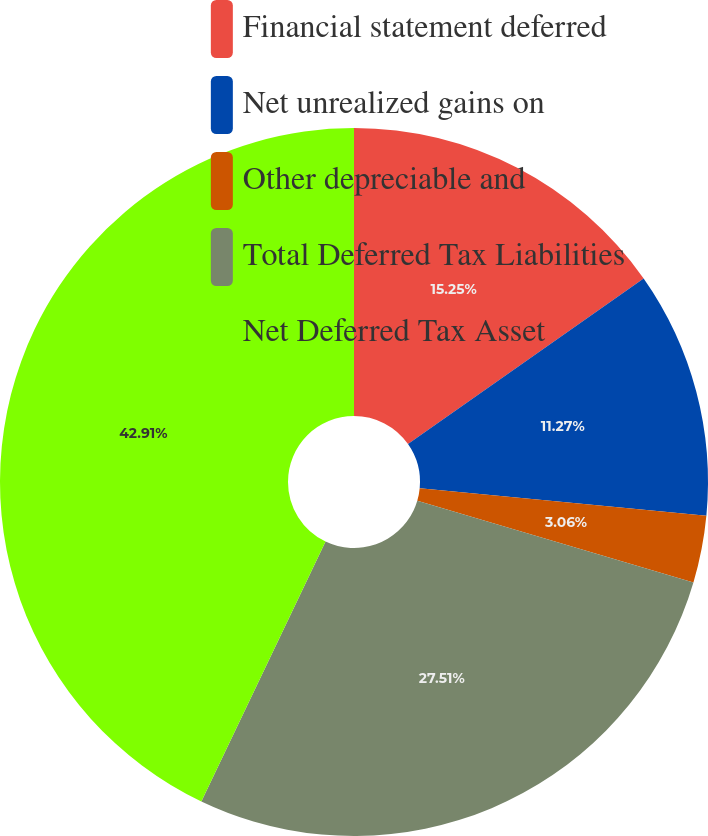Convert chart. <chart><loc_0><loc_0><loc_500><loc_500><pie_chart><fcel>Financial statement deferred<fcel>Net unrealized gains on<fcel>Other depreciable and<fcel>Total Deferred Tax Liabilities<fcel>Net Deferred Tax Asset<nl><fcel>15.25%<fcel>11.27%<fcel>3.06%<fcel>27.51%<fcel>42.9%<nl></chart> 